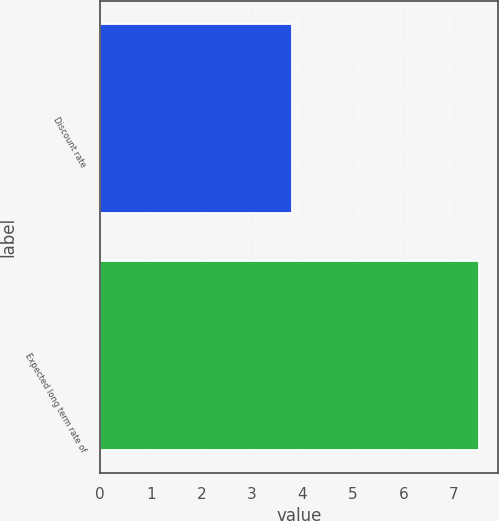Convert chart. <chart><loc_0><loc_0><loc_500><loc_500><bar_chart><fcel>Discount rate<fcel>Expected long term rate of<nl><fcel>3.8<fcel>7.5<nl></chart> 